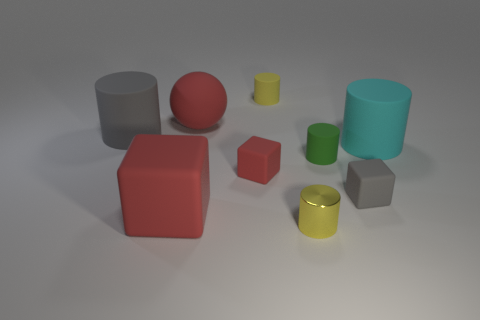What shape is the red rubber thing that is in front of the big gray thing and behind the small gray rubber thing?
Make the answer very short. Cube. Is the number of yellow rubber cylinders right of the metal cylinder the same as the number of large gray rubber things behind the big cyan matte object?
Provide a short and direct response. No. Is the shape of the tiny yellow thing in front of the cyan matte cylinder the same as  the small green rubber thing?
Keep it short and to the point. Yes. What number of yellow objects are either large matte cubes or tiny shiny things?
Your answer should be very brief. 1. There is a large thing that is the same shape as the tiny gray rubber object; what is its material?
Make the answer very short. Rubber. There is a small yellow object behind the tiny metallic thing; what is its shape?
Your answer should be very brief. Cylinder. Is there a tiny gray thing that has the same material as the small green cylinder?
Offer a very short reply. Yes. Is the size of the yellow rubber thing the same as the green rubber object?
Provide a short and direct response. Yes. How many cylinders are either big brown metal things or tiny green rubber objects?
Provide a succinct answer. 1. What material is the small cube that is the same color as the large ball?
Give a very brief answer. Rubber. 